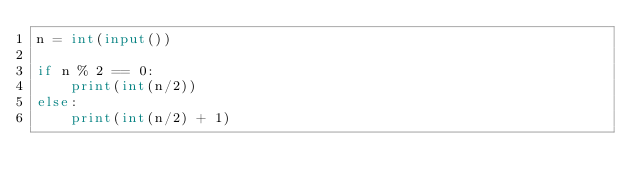<code> <loc_0><loc_0><loc_500><loc_500><_Python_>n = int(input())

if n % 2 == 0:
    print(int(n/2))
else:
    print(int(n/2) + 1)    </code> 